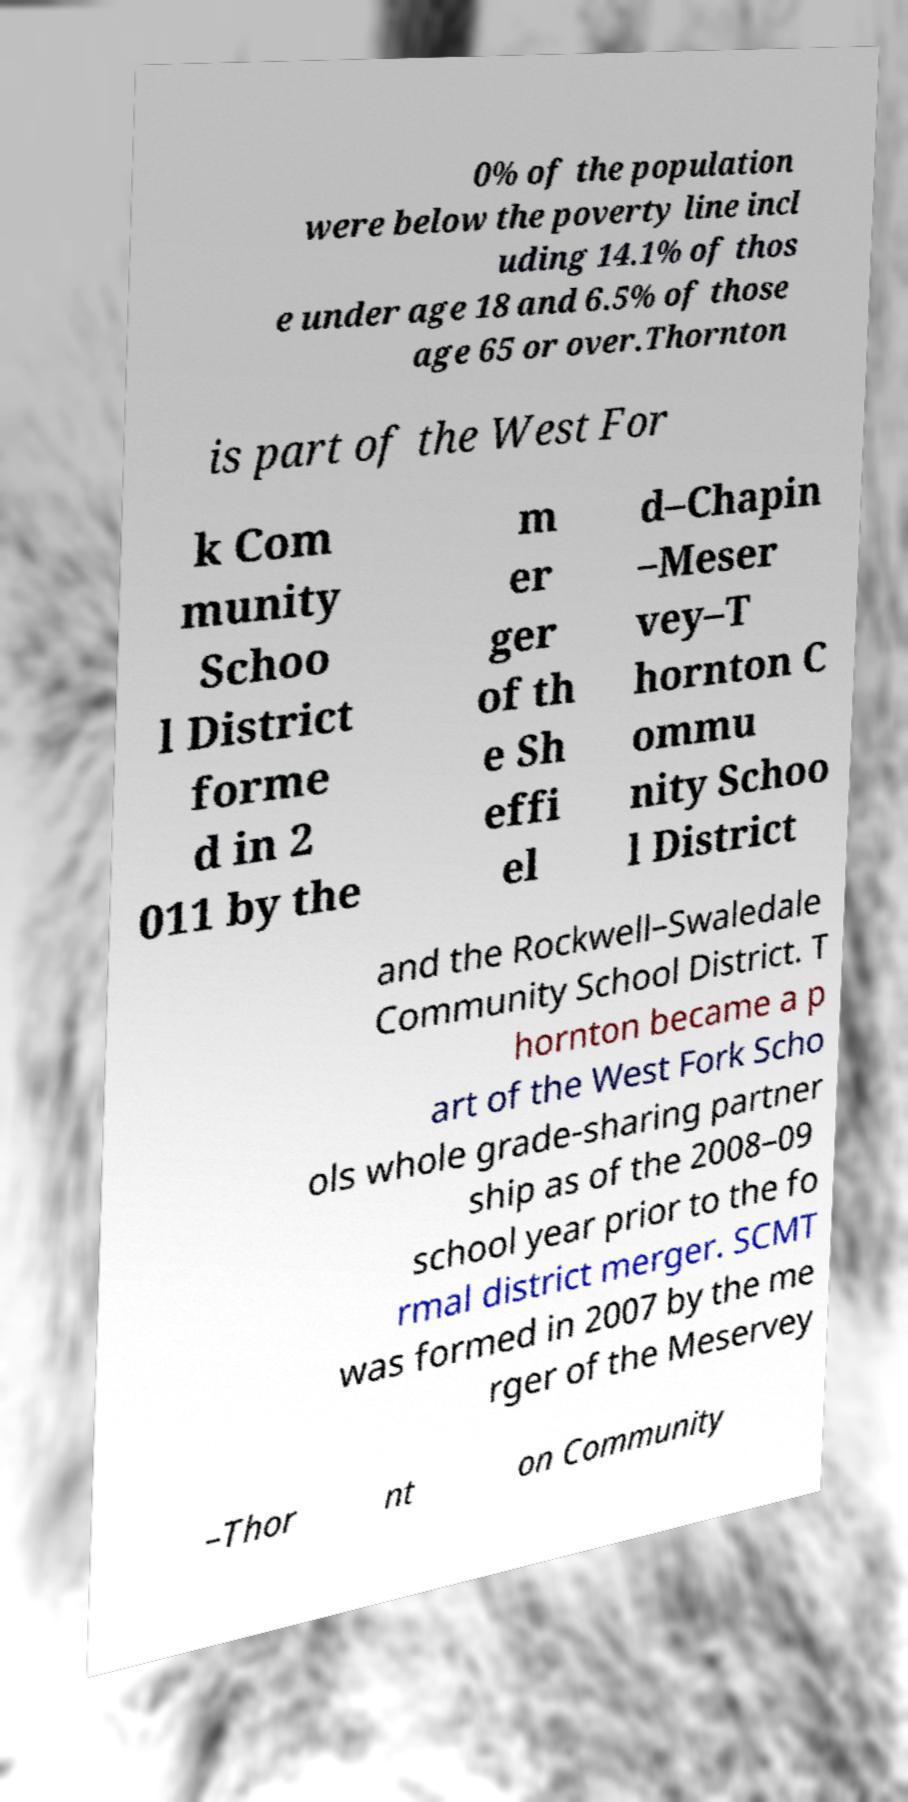Please identify and transcribe the text found in this image. 0% of the population were below the poverty line incl uding 14.1% of thos e under age 18 and 6.5% of those age 65 or over.Thornton is part of the West For k Com munity Schoo l District forme d in 2 011 by the m er ger of th e Sh effi el d–Chapin –Meser vey–T hornton C ommu nity Schoo l District and the Rockwell–Swaledale Community School District. T hornton became a p art of the West Fork Scho ols whole grade-sharing partner ship as of the 2008–09 school year prior to the fo rmal district merger. SCMT was formed in 2007 by the me rger of the Meservey –Thor nt on Community 